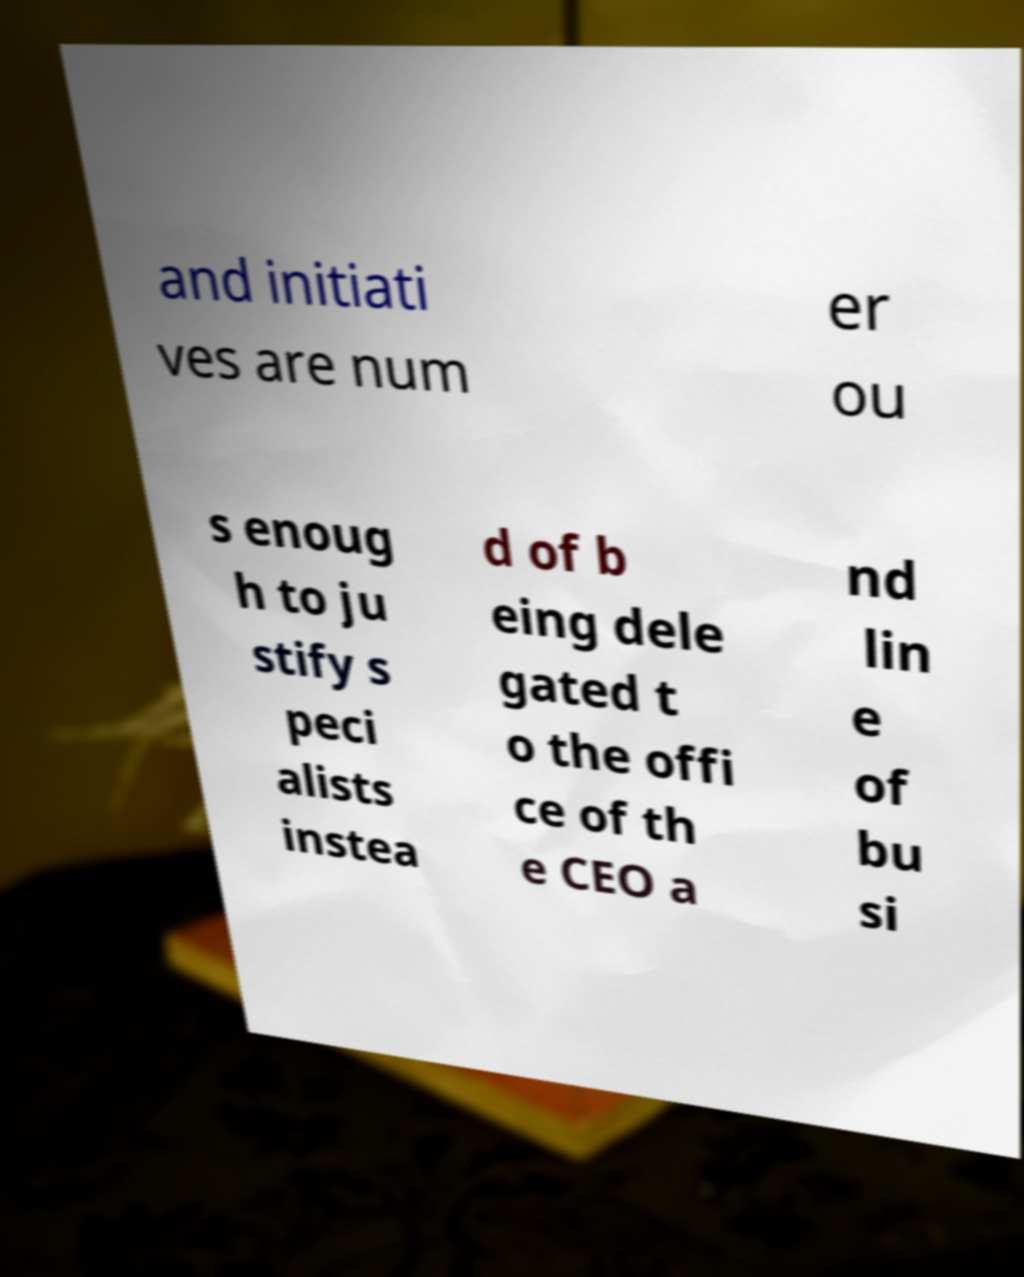What messages or text are displayed in this image? I need them in a readable, typed format. and initiati ves are num er ou s enoug h to ju stify s peci alists instea d of b eing dele gated t o the offi ce of th e CEO a nd lin e of bu si 